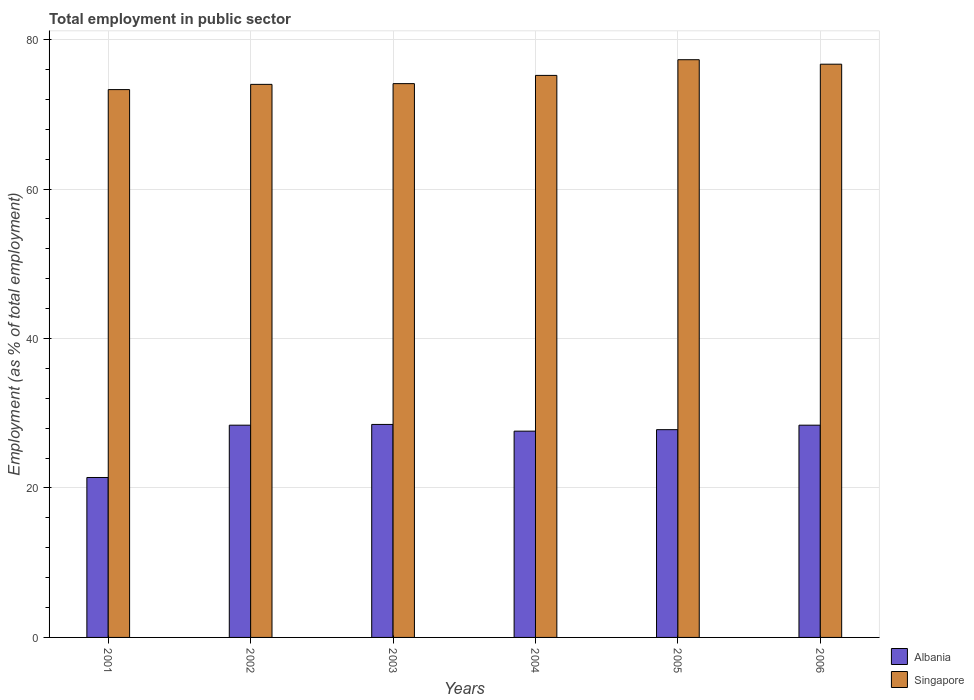How many groups of bars are there?
Give a very brief answer. 6. Are the number of bars per tick equal to the number of legend labels?
Provide a succinct answer. Yes. Are the number of bars on each tick of the X-axis equal?
Give a very brief answer. Yes. How many bars are there on the 3rd tick from the right?
Give a very brief answer. 2. What is the label of the 4th group of bars from the left?
Your answer should be compact. 2004. In how many cases, is the number of bars for a given year not equal to the number of legend labels?
Offer a terse response. 0. Across all years, what is the maximum employment in public sector in Singapore?
Ensure brevity in your answer.  77.3. Across all years, what is the minimum employment in public sector in Singapore?
Keep it short and to the point. 73.3. In which year was the employment in public sector in Singapore minimum?
Provide a succinct answer. 2001. What is the total employment in public sector in Albania in the graph?
Give a very brief answer. 162.1. What is the difference between the employment in public sector in Singapore in 2001 and that in 2004?
Offer a very short reply. -1.9. What is the difference between the employment in public sector in Albania in 2006 and the employment in public sector in Singapore in 2004?
Keep it short and to the point. -46.8. What is the average employment in public sector in Singapore per year?
Keep it short and to the point. 75.1. In the year 2002, what is the difference between the employment in public sector in Albania and employment in public sector in Singapore?
Ensure brevity in your answer.  -45.6. In how many years, is the employment in public sector in Albania greater than 40 %?
Your answer should be very brief. 0. What is the ratio of the employment in public sector in Singapore in 2003 to that in 2004?
Provide a succinct answer. 0.99. What is the difference between the highest and the second highest employment in public sector in Singapore?
Provide a short and direct response. 0.6. What is the difference between the highest and the lowest employment in public sector in Singapore?
Offer a terse response. 4. Is the sum of the employment in public sector in Singapore in 2003 and 2005 greater than the maximum employment in public sector in Albania across all years?
Offer a terse response. Yes. What does the 1st bar from the left in 2006 represents?
Your answer should be very brief. Albania. What does the 1st bar from the right in 2003 represents?
Make the answer very short. Singapore. Are all the bars in the graph horizontal?
Offer a terse response. No. How many years are there in the graph?
Your answer should be compact. 6. Does the graph contain grids?
Ensure brevity in your answer.  Yes. Where does the legend appear in the graph?
Provide a succinct answer. Bottom right. How many legend labels are there?
Ensure brevity in your answer.  2. How are the legend labels stacked?
Provide a succinct answer. Vertical. What is the title of the graph?
Make the answer very short. Total employment in public sector. Does "Pacific island small states" appear as one of the legend labels in the graph?
Offer a terse response. No. What is the label or title of the Y-axis?
Ensure brevity in your answer.  Employment (as % of total employment). What is the Employment (as % of total employment) of Albania in 2001?
Make the answer very short. 21.4. What is the Employment (as % of total employment) in Singapore in 2001?
Offer a terse response. 73.3. What is the Employment (as % of total employment) of Albania in 2002?
Your answer should be very brief. 28.4. What is the Employment (as % of total employment) of Singapore in 2003?
Keep it short and to the point. 74.1. What is the Employment (as % of total employment) of Albania in 2004?
Offer a very short reply. 27.6. What is the Employment (as % of total employment) of Singapore in 2004?
Offer a very short reply. 75.2. What is the Employment (as % of total employment) in Albania in 2005?
Keep it short and to the point. 27.8. What is the Employment (as % of total employment) in Singapore in 2005?
Keep it short and to the point. 77.3. What is the Employment (as % of total employment) in Albania in 2006?
Ensure brevity in your answer.  28.4. What is the Employment (as % of total employment) in Singapore in 2006?
Ensure brevity in your answer.  76.7. Across all years, what is the maximum Employment (as % of total employment) of Albania?
Provide a short and direct response. 28.5. Across all years, what is the maximum Employment (as % of total employment) of Singapore?
Your answer should be very brief. 77.3. Across all years, what is the minimum Employment (as % of total employment) in Albania?
Offer a terse response. 21.4. Across all years, what is the minimum Employment (as % of total employment) in Singapore?
Your response must be concise. 73.3. What is the total Employment (as % of total employment) of Albania in the graph?
Make the answer very short. 162.1. What is the total Employment (as % of total employment) of Singapore in the graph?
Your answer should be very brief. 450.6. What is the difference between the Employment (as % of total employment) in Albania in 2001 and that in 2002?
Offer a very short reply. -7. What is the difference between the Employment (as % of total employment) of Singapore in 2001 and that in 2003?
Provide a succinct answer. -0.8. What is the difference between the Employment (as % of total employment) of Singapore in 2001 and that in 2004?
Make the answer very short. -1.9. What is the difference between the Employment (as % of total employment) of Albania in 2001 and that in 2006?
Your answer should be compact. -7. What is the difference between the Employment (as % of total employment) of Singapore in 2002 and that in 2003?
Offer a very short reply. -0.1. What is the difference between the Employment (as % of total employment) in Albania in 2002 and that in 2004?
Give a very brief answer. 0.8. What is the difference between the Employment (as % of total employment) in Singapore in 2002 and that in 2004?
Provide a short and direct response. -1.2. What is the difference between the Employment (as % of total employment) of Albania in 2002 and that in 2005?
Give a very brief answer. 0.6. What is the difference between the Employment (as % of total employment) in Singapore in 2002 and that in 2005?
Keep it short and to the point. -3.3. What is the difference between the Employment (as % of total employment) of Albania in 2003 and that in 2004?
Offer a terse response. 0.9. What is the difference between the Employment (as % of total employment) in Albania in 2003 and that in 2005?
Your answer should be very brief. 0.7. What is the difference between the Employment (as % of total employment) in Singapore in 2003 and that in 2005?
Your answer should be very brief. -3.2. What is the difference between the Employment (as % of total employment) of Albania in 2005 and that in 2006?
Keep it short and to the point. -0.6. What is the difference between the Employment (as % of total employment) of Singapore in 2005 and that in 2006?
Your answer should be very brief. 0.6. What is the difference between the Employment (as % of total employment) in Albania in 2001 and the Employment (as % of total employment) in Singapore in 2002?
Provide a short and direct response. -52.6. What is the difference between the Employment (as % of total employment) of Albania in 2001 and the Employment (as % of total employment) of Singapore in 2003?
Keep it short and to the point. -52.7. What is the difference between the Employment (as % of total employment) in Albania in 2001 and the Employment (as % of total employment) in Singapore in 2004?
Provide a short and direct response. -53.8. What is the difference between the Employment (as % of total employment) in Albania in 2001 and the Employment (as % of total employment) in Singapore in 2005?
Keep it short and to the point. -55.9. What is the difference between the Employment (as % of total employment) of Albania in 2001 and the Employment (as % of total employment) of Singapore in 2006?
Your answer should be very brief. -55.3. What is the difference between the Employment (as % of total employment) in Albania in 2002 and the Employment (as % of total employment) in Singapore in 2003?
Your response must be concise. -45.7. What is the difference between the Employment (as % of total employment) in Albania in 2002 and the Employment (as % of total employment) in Singapore in 2004?
Offer a terse response. -46.8. What is the difference between the Employment (as % of total employment) in Albania in 2002 and the Employment (as % of total employment) in Singapore in 2005?
Give a very brief answer. -48.9. What is the difference between the Employment (as % of total employment) in Albania in 2002 and the Employment (as % of total employment) in Singapore in 2006?
Provide a succinct answer. -48.3. What is the difference between the Employment (as % of total employment) of Albania in 2003 and the Employment (as % of total employment) of Singapore in 2004?
Your answer should be very brief. -46.7. What is the difference between the Employment (as % of total employment) in Albania in 2003 and the Employment (as % of total employment) in Singapore in 2005?
Your answer should be compact. -48.8. What is the difference between the Employment (as % of total employment) of Albania in 2003 and the Employment (as % of total employment) of Singapore in 2006?
Keep it short and to the point. -48.2. What is the difference between the Employment (as % of total employment) of Albania in 2004 and the Employment (as % of total employment) of Singapore in 2005?
Offer a very short reply. -49.7. What is the difference between the Employment (as % of total employment) in Albania in 2004 and the Employment (as % of total employment) in Singapore in 2006?
Provide a short and direct response. -49.1. What is the difference between the Employment (as % of total employment) in Albania in 2005 and the Employment (as % of total employment) in Singapore in 2006?
Your answer should be compact. -48.9. What is the average Employment (as % of total employment) in Albania per year?
Keep it short and to the point. 27.02. What is the average Employment (as % of total employment) of Singapore per year?
Make the answer very short. 75.1. In the year 2001, what is the difference between the Employment (as % of total employment) of Albania and Employment (as % of total employment) of Singapore?
Your answer should be very brief. -51.9. In the year 2002, what is the difference between the Employment (as % of total employment) of Albania and Employment (as % of total employment) of Singapore?
Offer a terse response. -45.6. In the year 2003, what is the difference between the Employment (as % of total employment) in Albania and Employment (as % of total employment) in Singapore?
Provide a short and direct response. -45.6. In the year 2004, what is the difference between the Employment (as % of total employment) of Albania and Employment (as % of total employment) of Singapore?
Provide a succinct answer. -47.6. In the year 2005, what is the difference between the Employment (as % of total employment) in Albania and Employment (as % of total employment) in Singapore?
Your answer should be very brief. -49.5. In the year 2006, what is the difference between the Employment (as % of total employment) in Albania and Employment (as % of total employment) in Singapore?
Provide a succinct answer. -48.3. What is the ratio of the Employment (as % of total employment) in Albania in 2001 to that in 2002?
Provide a short and direct response. 0.75. What is the ratio of the Employment (as % of total employment) of Albania in 2001 to that in 2003?
Offer a terse response. 0.75. What is the ratio of the Employment (as % of total employment) of Albania in 2001 to that in 2004?
Offer a terse response. 0.78. What is the ratio of the Employment (as % of total employment) in Singapore in 2001 to that in 2004?
Make the answer very short. 0.97. What is the ratio of the Employment (as % of total employment) in Albania in 2001 to that in 2005?
Your answer should be very brief. 0.77. What is the ratio of the Employment (as % of total employment) in Singapore in 2001 to that in 2005?
Keep it short and to the point. 0.95. What is the ratio of the Employment (as % of total employment) in Albania in 2001 to that in 2006?
Provide a short and direct response. 0.75. What is the ratio of the Employment (as % of total employment) of Singapore in 2001 to that in 2006?
Provide a succinct answer. 0.96. What is the ratio of the Employment (as % of total employment) in Albania in 2002 to that in 2003?
Your response must be concise. 1. What is the ratio of the Employment (as % of total employment) of Albania in 2002 to that in 2005?
Make the answer very short. 1.02. What is the ratio of the Employment (as % of total employment) of Singapore in 2002 to that in 2005?
Your answer should be compact. 0.96. What is the ratio of the Employment (as % of total employment) of Singapore in 2002 to that in 2006?
Offer a terse response. 0.96. What is the ratio of the Employment (as % of total employment) of Albania in 2003 to that in 2004?
Give a very brief answer. 1.03. What is the ratio of the Employment (as % of total employment) in Singapore in 2003 to that in 2004?
Your response must be concise. 0.99. What is the ratio of the Employment (as % of total employment) in Albania in 2003 to that in 2005?
Give a very brief answer. 1.03. What is the ratio of the Employment (as % of total employment) in Singapore in 2003 to that in 2005?
Offer a very short reply. 0.96. What is the ratio of the Employment (as % of total employment) of Albania in 2003 to that in 2006?
Offer a terse response. 1. What is the ratio of the Employment (as % of total employment) in Singapore in 2003 to that in 2006?
Give a very brief answer. 0.97. What is the ratio of the Employment (as % of total employment) in Albania in 2004 to that in 2005?
Give a very brief answer. 0.99. What is the ratio of the Employment (as % of total employment) in Singapore in 2004 to that in 2005?
Offer a terse response. 0.97. What is the ratio of the Employment (as % of total employment) in Albania in 2004 to that in 2006?
Ensure brevity in your answer.  0.97. What is the ratio of the Employment (as % of total employment) of Singapore in 2004 to that in 2006?
Give a very brief answer. 0.98. What is the ratio of the Employment (as % of total employment) in Albania in 2005 to that in 2006?
Offer a very short reply. 0.98. What is the ratio of the Employment (as % of total employment) in Singapore in 2005 to that in 2006?
Your response must be concise. 1.01. What is the difference between the highest and the second highest Employment (as % of total employment) in Albania?
Offer a terse response. 0.1. What is the difference between the highest and the lowest Employment (as % of total employment) of Singapore?
Ensure brevity in your answer.  4. 